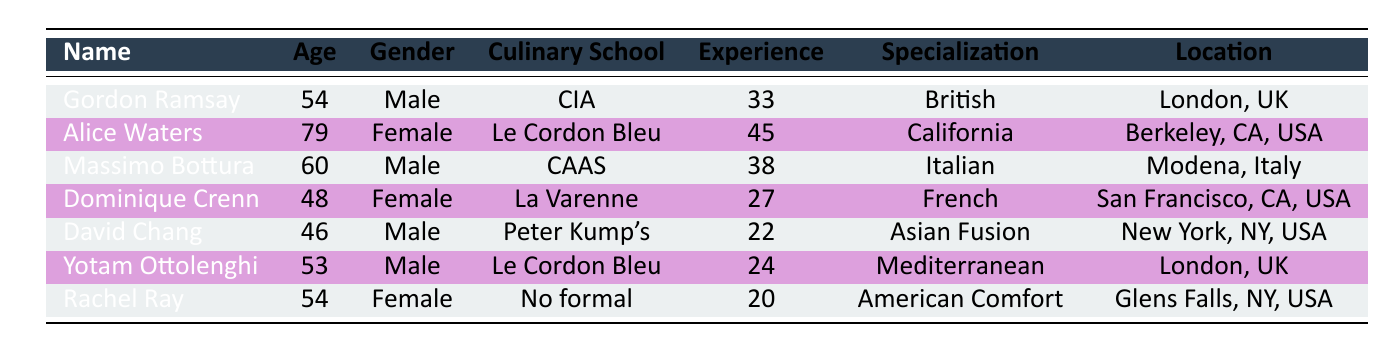What is the age of Dominique Crenn? The age of Dominique Crenn is listed directly in the table, which states she is 48 years old.
Answer: 48 Which chef has the highest years of experience? By looking through the list, Alice Waters has the most years of experience at 45 years.
Answer: Alice Waters What is the average age of the chefs? To find the average age, we sum the ages (54 + 79 + 60 + 48 + 46 + 53 + 54) = 394. There are 7 chefs, so the average age is 394/7 ≈ 56.29.
Answer: 56.29 Is Massimo Bottura specialized in French cuisine? In the table, Massimo Bottura's specialization is listed as Italian cuisine, not French. Therefore, this statement is false.
Answer: No How many chefs are located in the USA? By scanning the location column, we identify the chefs in the USA: Alice Waters, Dominique Crenn, David Chang, and Rachel Ray, totaling four.
Answer: 4 What is the total years of experience of chefs who specialize in Asian Fusion and Mediterranean cuisine? David Chang specializes in Asian Fusion with 22 years of experience, and Yotam Ottolenghi specializes in Mediterranean cuisine with 24 years. So the total experience is 22 + 24 = 46 years.
Answer: 46 Are there more female chefs than male chefs in this group? There are three female chefs (Alice Waters, Dominique Crenn, Rachel Ray) and four male chefs (Gordon Ramsay, Massimo Bottura, David Chang, Yotam Ottolenghi). Thus, there are more males than females.
Answer: No What percentage of the chefs attended Le Cordon Bleu? There are two chefs who attended Le Cordon Bleu (Alice Waters and Yotam Ottolenghi) out of a total of seven chefs. The percentage is calculated as (2/7) * 100 ≈ 28.57%.
Answer: 28.57% Which chef has a specialization in American Comfort Food? The table indicates that Rachel Ray's specialization is American Comfort Food.
Answer: Rachel Ray 